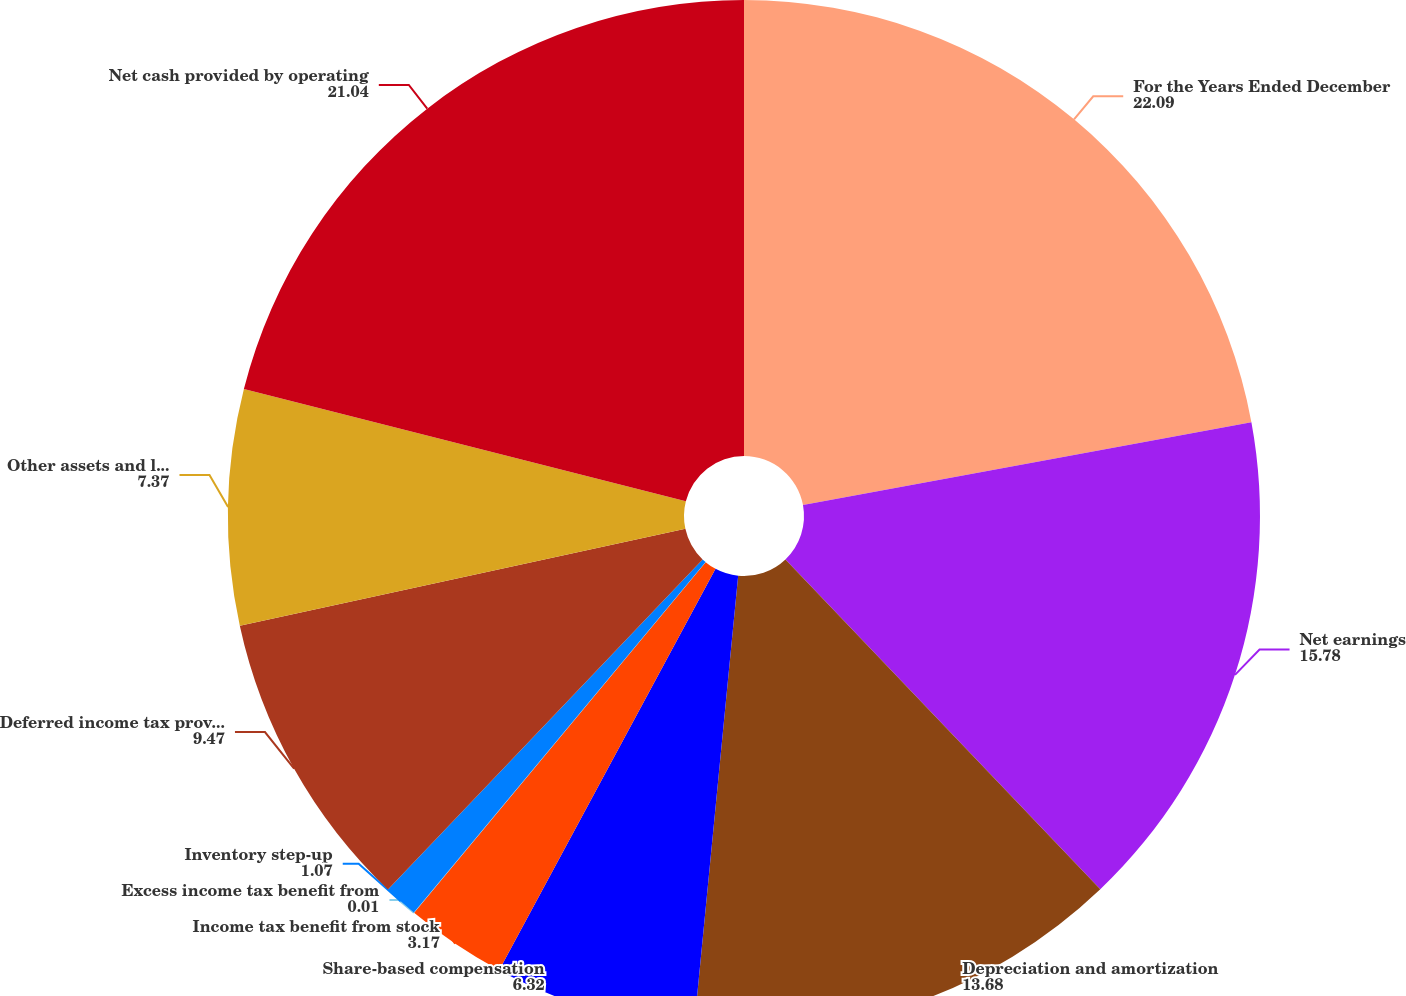Convert chart. <chart><loc_0><loc_0><loc_500><loc_500><pie_chart><fcel>For the Years Ended December<fcel>Net earnings<fcel>Depreciation and amortization<fcel>Share-based compensation<fcel>Income tax benefit from stock<fcel>Excess income tax benefit from<fcel>Inventory step-up<fcel>Deferred income tax provision<fcel>Other assets and liabilities<fcel>Net cash provided by operating<nl><fcel>22.09%<fcel>15.78%<fcel>13.68%<fcel>6.32%<fcel>3.17%<fcel>0.01%<fcel>1.07%<fcel>9.47%<fcel>7.37%<fcel>21.04%<nl></chart> 